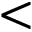Convert formula to latex. <formula><loc_0><loc_0><loc_500><loc_500><</formula> 